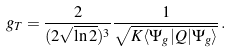Convert formula to latex. <formula><loc_0><loc_0><loc_500><loc_500>g _ { T } = \frac { 2 } { ( 2 \sqrt { \ln 2 } ) ^ { 3 } } \frac { 1 } { \sqrt { K \langle \Psi _ { g } | Q | \Psi _ { g } \rangle } } \, .</formula> 